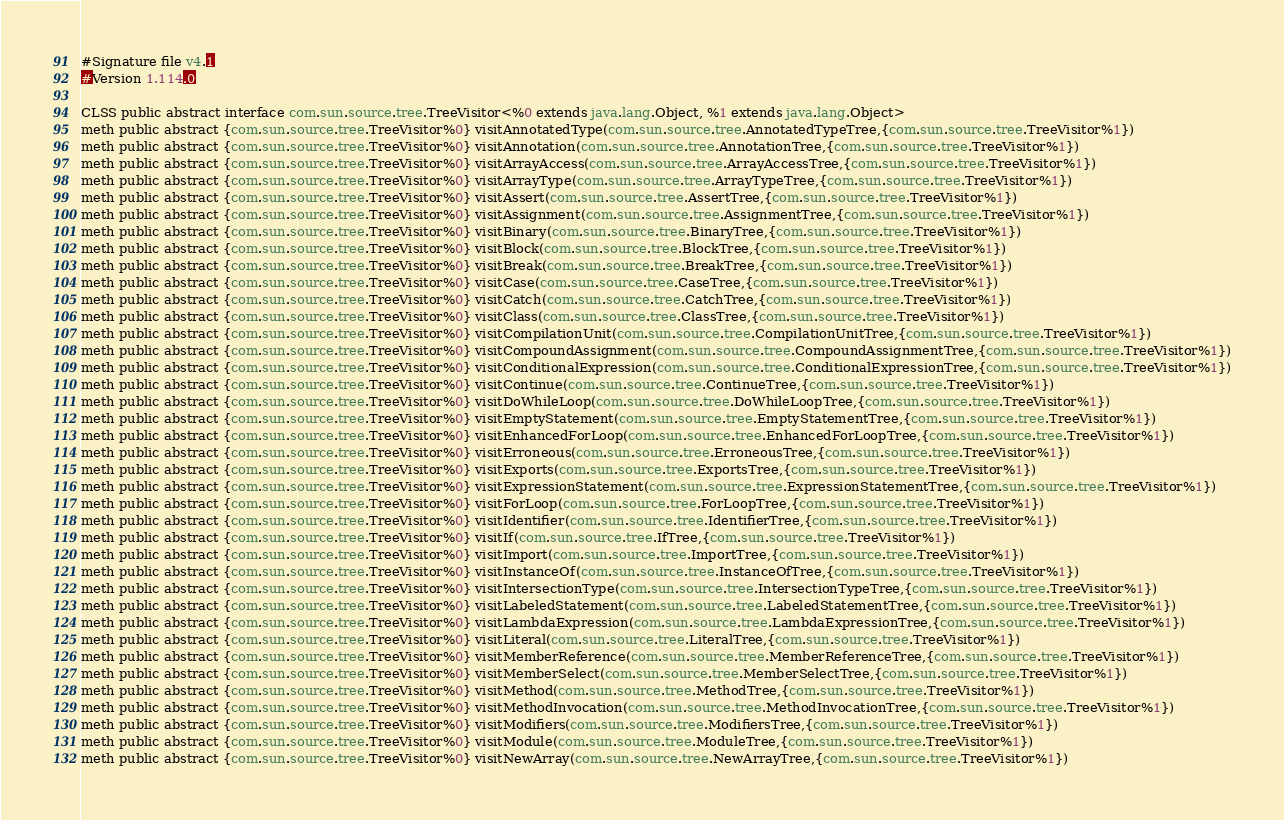Convert code to text. <code><loc_0><loc_0><loc_500><loc_500><_SML_>#Signature file v4.1
#Version 1.114.0

CLSS public abstract interface com.sun.source.tree.TreeVisitor<%0 extends java.lang.Object, %1 extends java.lang.Object>
meth public abstract {com.sun.source.tree.TreeVisitor%0} visitAnnotatedType(com.sun.source.tree.AnnotatedTypeTree,{com.sun.source.tree.TreeVisitor%1})
meth public abstract {com.sun.source.tree.TreeVisitor%0} visitAnnotation(com.sun.source.tree.AnnotationTree,{com.sun.source.tree.TreeVisitor%1})
meth public abstract {com.sun.source.tree.TreeVisitor%0} visitArrayAccess(com.sun.source.tree.ArrayAccessTree,{com.sun.source.tree.TreeVisitor%1})
meth public abstract {com.sun.source.tree.TreeVisitor%0} visitArrayType(com.sun.source.tree.ArrayTypeTree,{com.sun.source.tree.TreeVisitor%1})
meth public abstract {com.sun.source.tree.TreeVisitor%0} visitAssert(com.sun.source.tree.AssertTree,{com.sun.source.tree.TreeVisitor%1})
meth public abstract {com.sun.source.tree.TreeVisitor%0} visitAssignment(com.sun.source.tree.AssignmentTree,{com.sun.source.tree.TreeVisitor%1})
meth public abstract {com.sun.source.tree.TreeVisitor%0} visitBinary(com.sun.source.tree.BinaryTree,{com.sun.source.tree.TreeVisitor%1})
meth public abstract {com.sun.source.tree.TreeVisitor%0} visitBlock(com.sun.source.tree.BlockTree,{com.sun.source.tree.TreeVisitor%1})
meth public abstract {com.sun.source.tree.TreeVisitor%0} visitBreak(com.sun.source.tree.BreakTree,{com.sun.source.tree.TreeVisitor%1})
meth public abstract {com.sun.source.tree.TreeVisitor%0} visitCase(com.sun.source.tree.CaseTree,{com.sun.source.tree.TreeVisitor%1})
meth public abstract {com.sun.source.tree.TreeVisitor%0} visitCatch(com.sun.source.tree.CatchTree,{com.sun.source.tree.TreeVisitor%1})
meth public abstract {com.sun.source.tree.TreeVisitor%0} visitClass(com.sun.source.tree.ClassTree,{com.sun.source.tree.TreeVisitor%1})
meth public abstract {com.sun.source.tree.TreeVisitor%0} visitCompilationUnit(com.sun.source.tree.CompilationUnitTree,{com.sun.source.tree.TreeVisitor%1})
meth public abstract {com.sun.source.tree.TreeVisitor%0} visitCompoundAssignment(com.sun.source.tree.CompoundAssignmentTree,{com.sun.source.tree.TreeVisitor%1})
meth public abstract {com.sun.source.tree.TreeVisitor%0} visitConditionalExpression(com.sun.source.tree.ConditionalExpressionTree,{com.sun.source.tree.TreeVisitor%1})
meth public abstract {com.sun.source.tree.TreeVisitor%0} visitContinue(com.sun.source.tree.ContinueTree,{com.sun.source.tree.TreeVisitor%1})
meth public abstract {com.sun.source.tree.TreeVisitor%0} visitDoWhileLoop(com.sun.source.tree.DoWhileLoopTree,{com.sun.source.tree.TreeVisitor%1})
meth public abstract {com.sun.source.tree.TreeVisitor%0} visitEmptyStatement(com.sun.source.tree.EmptyStatementTree,{com.sun.source.tree.TreeVisitor%1})
meth public abstract {com.sun.source.tree.TreeVisitor%0} visitEnhancedForLoop(com.sun.source.tree.EnhancedForLoopTree,{com.sun.source.tree.TreeVisitor%1})
meth public abstract {com.sun.source.tree.TreeVisitor%0} visitErroneous(com.sun.source.tree.ErroneousTree,{com.sun.source.tree.TreeVisitor%1})
meth public abstract {com.sun.source.tree.TreeVisitor%0} visitExports(com.sun.source.tree.ExportsTree,{com.sun.source.tree.TreeVisitor%1})
meth public abstract {com.sun.source.tree.TreeVisitor%0} visitExpressionStatement(com.sun.source.tree.ExpressionStatementTree,{com.sun.source.tree.TreeVisitor%1})
meth public abstract {com.sun.source.tree.TreeVisitor%0} visitForLoop(com.sun.source.tree.ForLoopTree,{com.sun.source.tree.TreeVisitor%1})
meth public abstract {com.sun.source.tree.TreeVisitor%0} visitIdentifier(com.sun.source.tree.IdentifierTree,{com.sun.source.tree.TreeVisitor%1})
meth public abstract {com.sun.source.tree.TreeVisitor%0} visitIf(com.sun.source.tree.IfTree,{com.sun.source.tree.TreeVisitor%1})
meth public abstract {com.sun.source.tree.TreeVisitor%0} visitImport(com.sun.source.tree.ImportTree,{com.sun.source.tree.TreeVisitor%1})
meth public abstract {com.sun.source.tree.TreeVisitor%0} visitInstanceOf(com.sun.source.tree.InstanceOfTree,{com.sun.source.tree.TreeVisitor%1})
meth public abstract {com.sun.source.tree.TreeVisitor%0} visitIntersectionType(com.sun.source.tree.IntersectionTypeTree,{com.sun.source.tree.TreeVisitor%1})
meth public abstract {com.sun.source.tree.TreeVisitor%0} visitLabeledStatement(com.sun.source.tree.LabeledStatementTree,{com.sun.source.tree.TreeVisitor%1})
meth public abstract {com.sun.source.tree.TreeVisitor%0} visitLambdaExpression(com.sun.source.tree.LambdaExpressionTree,{com.sun.source.tree.TreeVisitor%1})
meth public abstract {com.sun.source.tree.TreeVisitor%0} visitLiteral(com.sun.source.tree.LiteralTree,{com.sun.source.tree.TreeVisitor%1})
meth public abstract {com.sun.source.tree.TreeVisitor%0} visitMemberReference(com.sun.source.tree.MemberReferenceTree,{com.sun.source.tree.TreeVisitor%1})
meth public abstract {com.sun.source.tree.TreeVisitor%0} visitMemberSelect(com.sun.source.tree.MemberSelectTree,{com.sun.source.tree.TreeVisitor%1})
meth public abstract {com.sun.source.tree.TreeVisitor%0} visitMethod(com.sun.source.tree.MethodTree,{com.sun.source.tree.TreeVisitor%1})
meth public abstract {com.sun.source.tree.TreeVisitor%0} visitMethodInvocation(com.sun.source.tree.MethodInvocationTree,{com.sun.source.tree.TreeVisitor%1})
meth public abstract {com.sun.source.tree.TreeVisitor%0} visitModifiers(com.sun.source.tree.ModifiersTree,{com.sun.source.tree.TreeVisitor%1})
meth public abstract {com.sun.source.tree.TreeVisitor%0} visitModule(com.sun.source.tree.ModuleTree,{com.sun.source.tree.TreeVisitor%1})
meth public abstract {com.sun.source.tree.TreeVisitor%0} visitNewArray(com.sun.source.tree.NewArrayTree,{com.sun.source.tree.TreeVisitor%1})</code> 